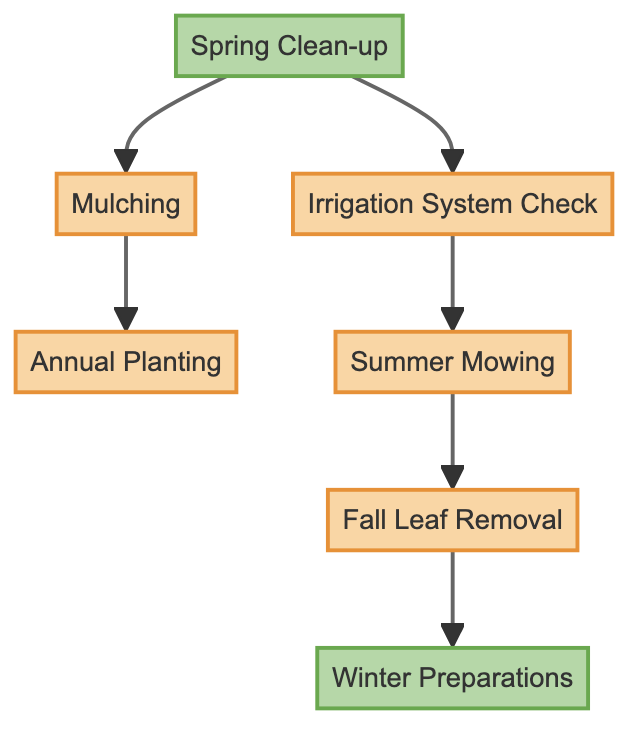What is the first task in the maintenance schedule? In the diagram, the first task indicated by the start node is "Spring Clean-up."
Answer: Spring Clean-up How many tasks are dependent on the "Spring Clean-up" task? The "Spring Clean-up" task has two outgoing edges leading to "Mulching" and "Irrigation System Check," indicating that two tasks depend on it.
Answer: 2 Which task comes immediately after "Irrigation System Check"? According to the arrows in the diagram, "Summer Mowing" is the task that is directly dependent on "Irrigation System Check."
Answer: Summer Mowing What is the final task in the sequence? The last task in the directed graph sequence, indicated by the end node, is "Winter Preparations."
Answer: Winter Preparations How many tasks are there in total in the diagram? The diagram features seven tasks, including the start and end nodes, leading to a total of seven tasks overall.
Answer: 7 Which task has only one dependency? The "Annual Planting" task is shown to have a single dependency, which is "Mulching."
Answer: Annual Planting What is the direct relationship between "Summer Mowing" and "Fall Leaf Removal"? "Summer Mowing" is a direct prerequisite for "Fall Leaf Removal," as shown by the directed edge connecting them.
Answer: Summer Mowing → Fall Leaf Removal What is the dependency path to perform "Fall Leaf Removal"? To reach "Fall Leaf Removal," one must complete "Summer Mowing," which relies on "Irrigation System Check," leading back to "Spring Clean-up." The full path is "Spring Clean-up" → "Irrigation System Check" → "Summer Mowing" → "Fall Leaf Removal."
Answer: Spring Clean-up → Irrigation System Check → Summer Mowing → Fall Leaf Removal 